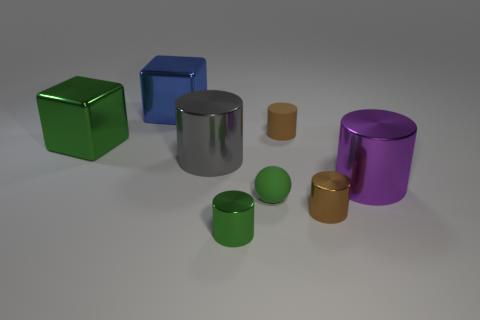What is the size of the cube that is the same color as the ball?
Give a very brief answer. Large. There is a large object that is the same color as the small rubber ball; what is it made of?
Your response must be concise. Metal. Are there any tiny metallic cylinders of the same color as the small rubber cylinder?
Your answer should be very brief. Yes. How many other metallic objects have the same shape as the big blue object?
Provide a short and direct response. 1. Are the ball on the right side of the gray cylinder and the brown cylinder that is behind the small green matte ball made of the same material?
Ensure brevity in your answer.  Yes. There is a brown object that is to the right of the small thing behind the purple object; what size is it?
Keep it short and to the point. Small. Is there anything else that has the same size as the matte sphere?
Your answer should be very brief. Yes. What is the material of the other large object that is the same shape as the gray object?
Keep it short and to the point. Metal. There is a tiny shiny object right of the tiny brown rubber cylinder; is it the same shape as the green shiny thing right of the gray object?
Your answer should be compact. Yes. Is the number of tiny balls greater than the number of small yellow metallic objects?
Ensure brevity in your answer.  Yes. 